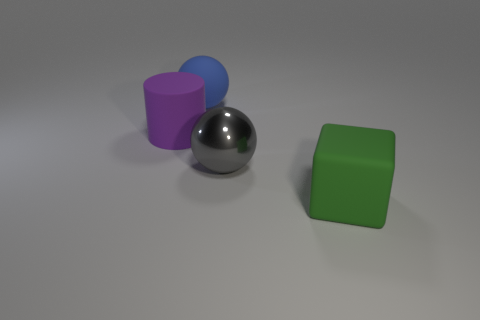Add 4 big blue metallic cylinders. How many objects exist? 8 Subtract all blocks. How many objects are left? 3 Add 3 blue balls. How many blue balls are left? 4 Add 2 large cyan metallic cylinders. How many large cyan metallic cylinders exist? 2 Subtract 0 green cylinders. How many objects are left? 4 Subtract all purple cubes. Subtract all large objects. How many objects are left? 0 